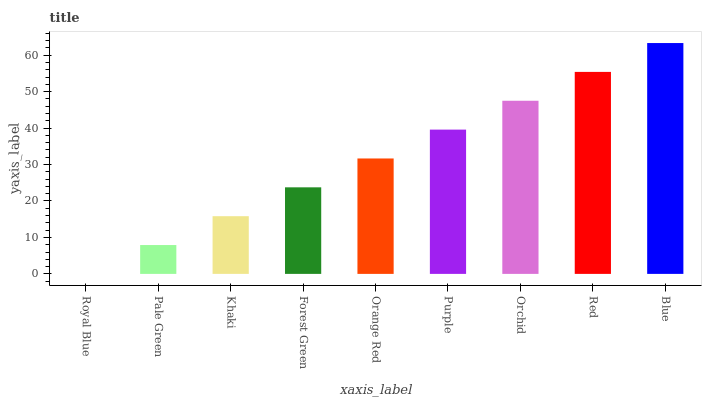Is Pale Green the minimum?
Answer yes or no. No. Is Pale Green the maximum?
Answer yes or no. No. Is Pale Green greater than Royal Blue?
Answer yes or no. Yes. Is Royal Blue less than Pale Green?
Answer yes or no. Yes. Is Royal Blue greater than Pale Green?
Answer yes or no. No. Is Pale Green less than Royal Blue?
Answer yes or no. No. Is Orange Red the high median?
Answer yes or no. Yes. Is Orange Red the low median?
Answer yes or no. Yes. Is Forest Green the high median?
Answer yes or no. No. Is Red the low median?
Answer yes or no. No. 